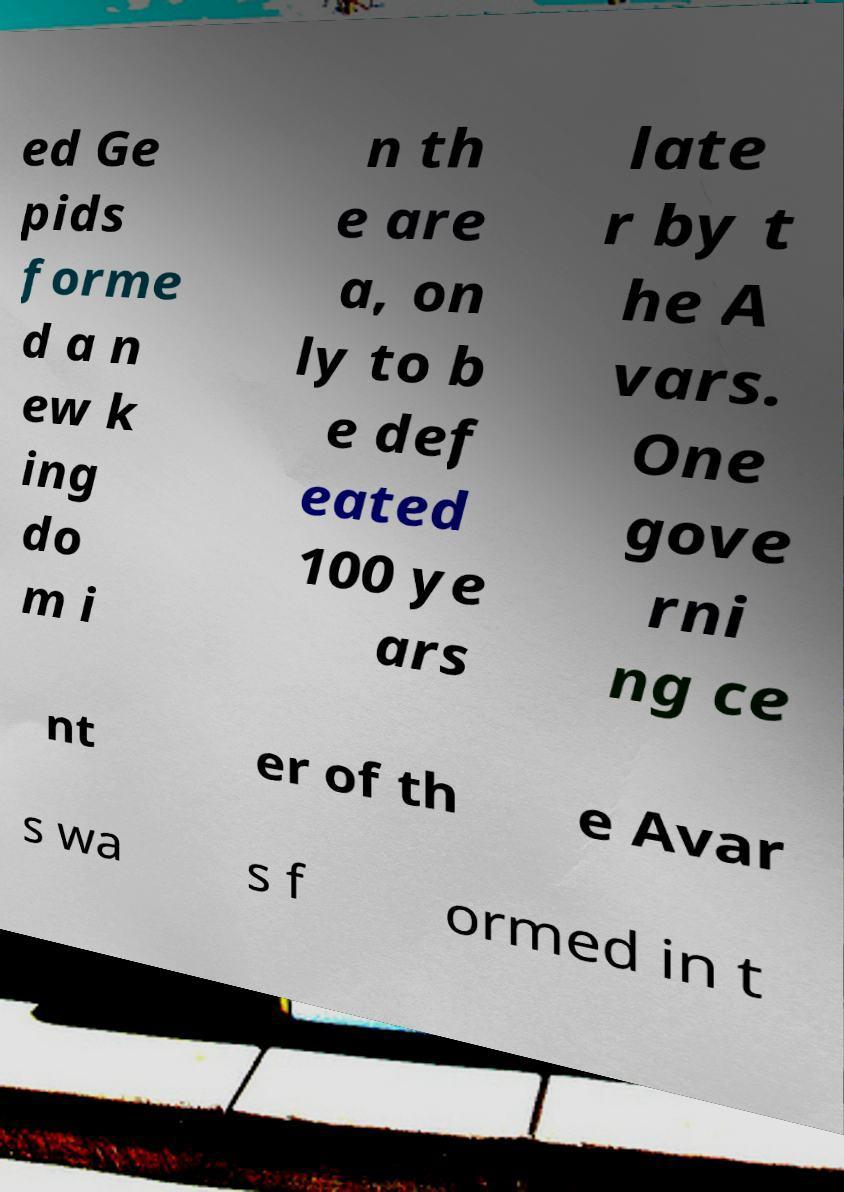For documentation purposes, I need the text within this image transcribed. Could you provide that? ed Ge pids forme d a n ew k ing do m i n th e are a, on ly to b e def eated 100 ye ars late r by t he A vars. One gove rni ng ce nt er of th e Avar s wa s f ormed in t 